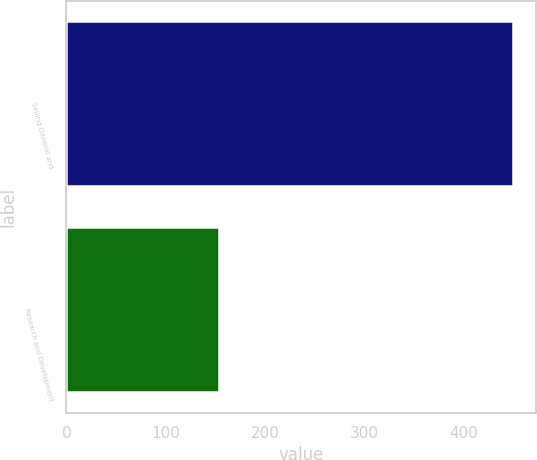Convert chart. <chart><loc_0><loc_0><loc_500><loc_500><bar_chart><fcel>Selling General and<fcel>Research and Development<nl><fcel>450<fcel>154<nl></chart> 